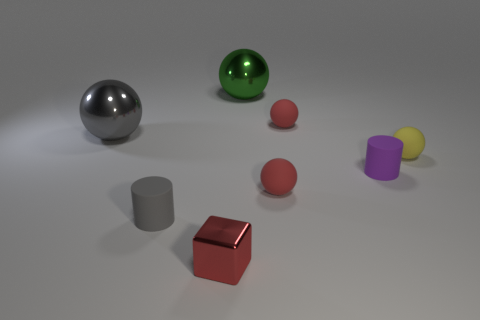How many red spheres must be subtracted to get 1 red spheres? 1 Subtract all green spheres. How many spheres are left? 4 Subtract all big gray balls. How many balls are left? 4 Subtract all blue balls. Subtract all green cylinders. How many balls are left? 5 Add 1 blue cubes. How many objects exist? 9 Subtract all balls. How many objects are left? 3 Subtract 0 purple cubes. How many objects are left? 8 Subtract all large brown balls. Subtract all yellow rubber objects. How many objects are left? 7 Add 4 gray shiny balls. How many gray shiny balls are left? 5 Add 3 gray things. How many gray things exist? 5 